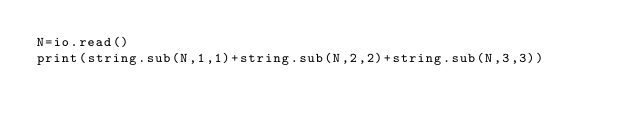<code> <loc_0><loc_0><loc_500><loc_500><_Lua_>N=io.read()
print(string.sub(N,1,1)+string.sub(N,2,2)+string.sub(N,3,3))</code> 